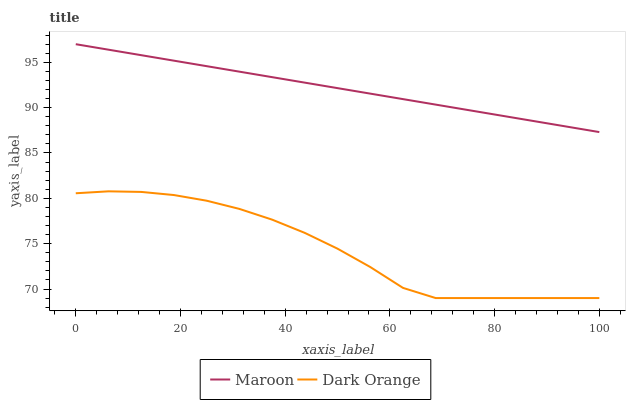Does Dark Orange have the minimum area under the curve?
Answer yes or no. Yes. Does Maroon have the maximum area under the curve?
Answer yes or no. Yes. Does Maroon have the minimum area under the curve?
Answer yes or no. No. Is Maroon the smoothest?
Answer yes or no. Yes. Is Dark Orange the roughest?
Answer yes or no. Yes. Is Maroon the roughest?
Answer yes or no. No. Does Maroon have the lowest value?
Answer yes or no. No. Does Maroon have the highest value?
Answer yes or no. Yes. Is Dark Orange less than Maroon?
Answer yes or no. Yes. Is Maroon greater than Dark Orange?
Answer yes or no. Yes. Does Dark Orange intersect Maroon?
Answer yes or no. No. 